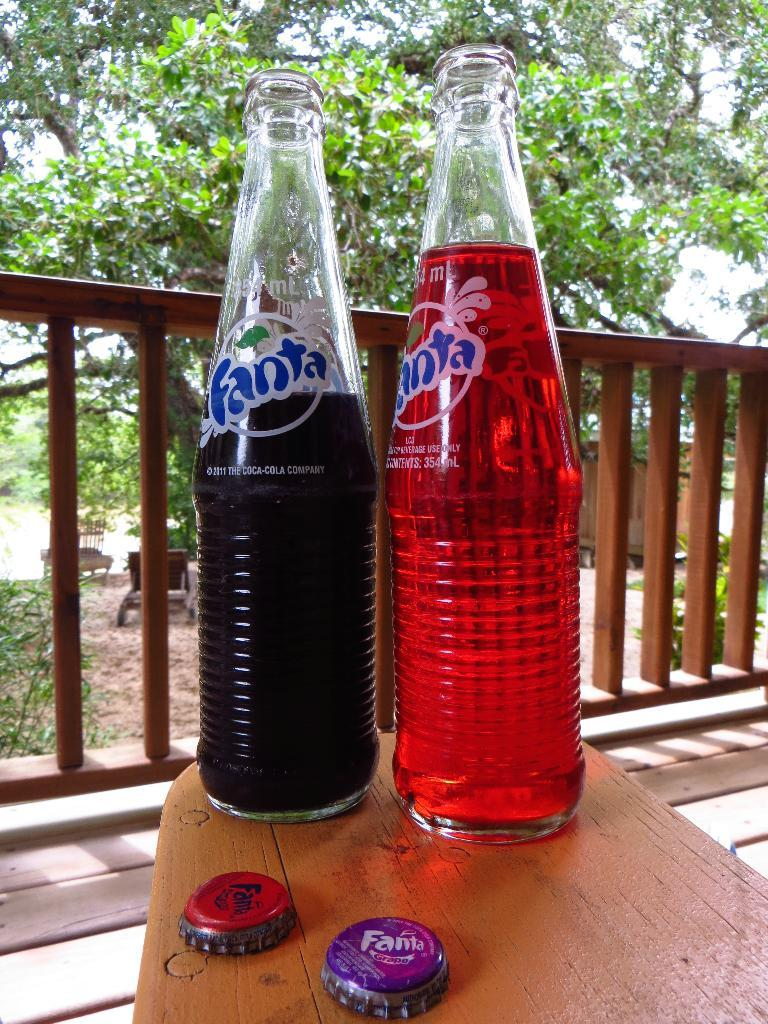<image>
Give a short and clear explanation of the subsequent image. two bottles of fanta, one red and one dark purple 